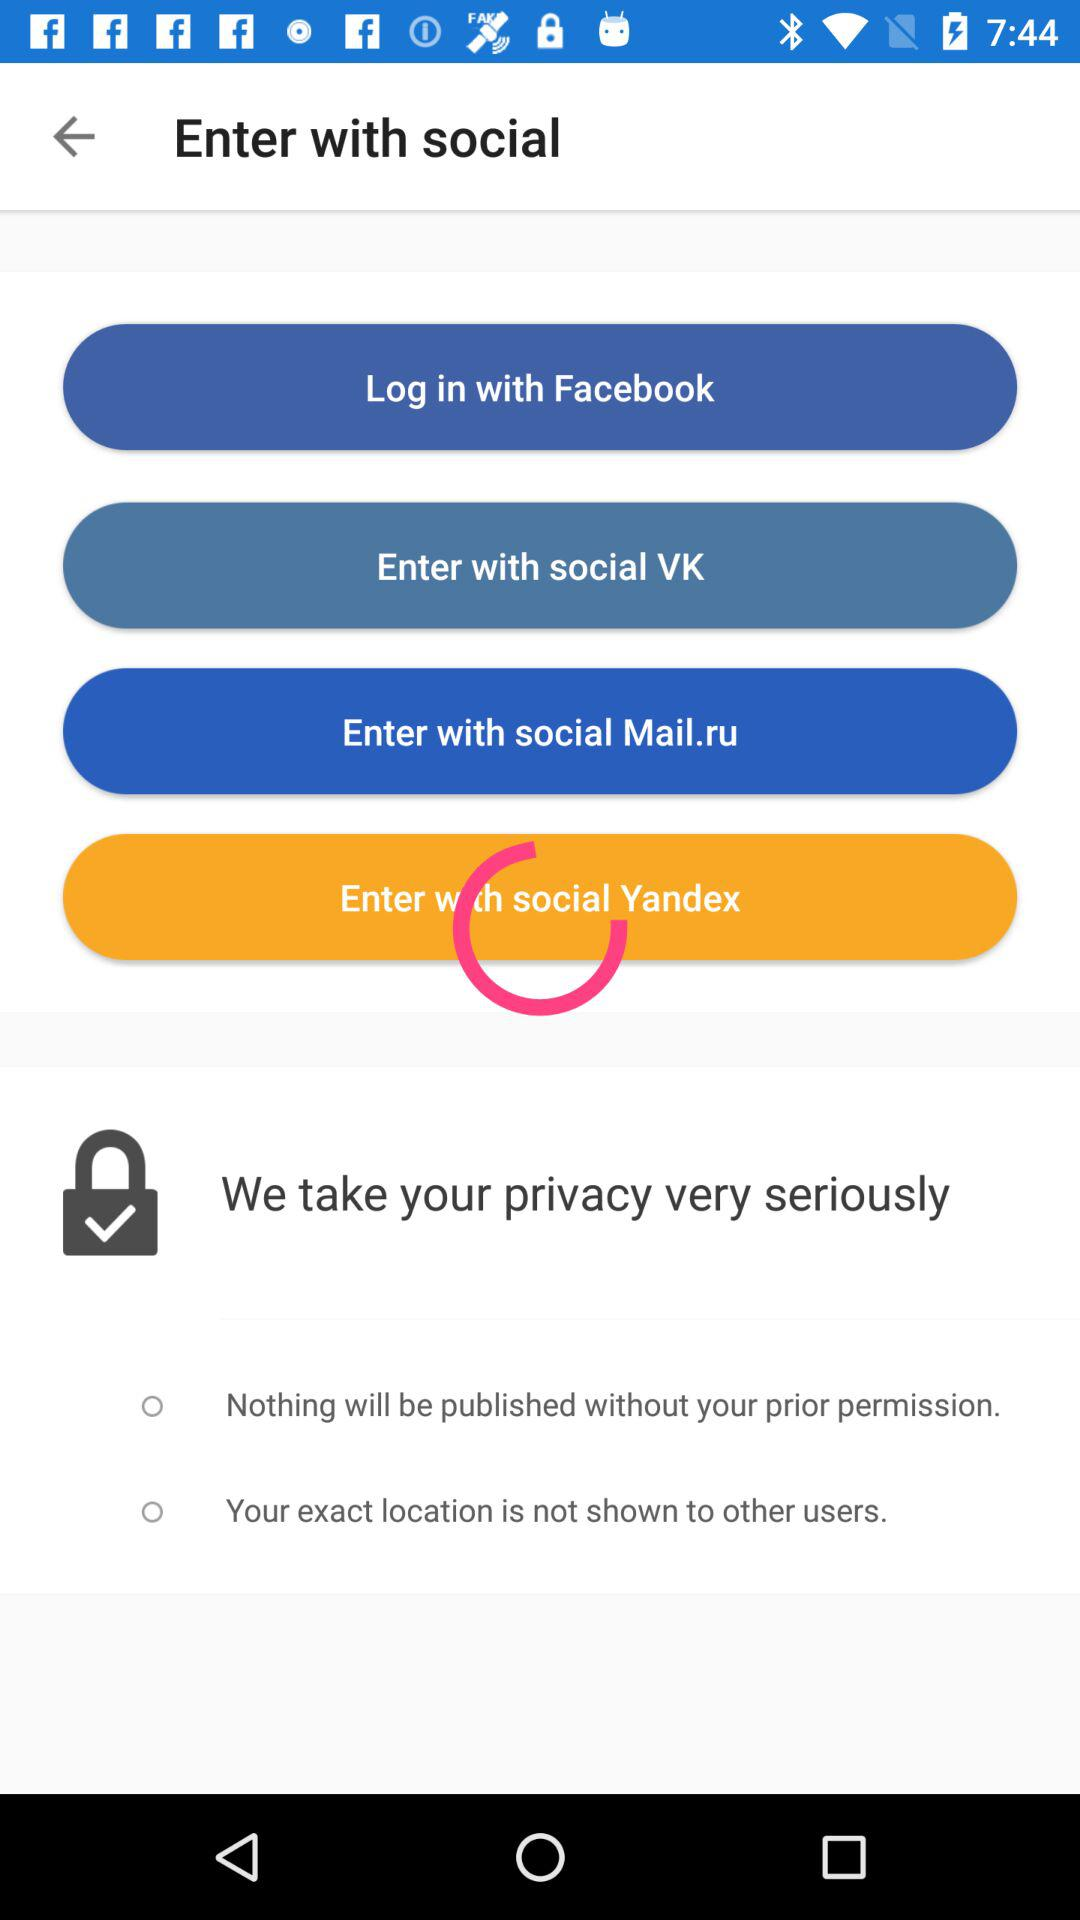How many privacy options are there?
Answer the question using a single word or phrase. 2 